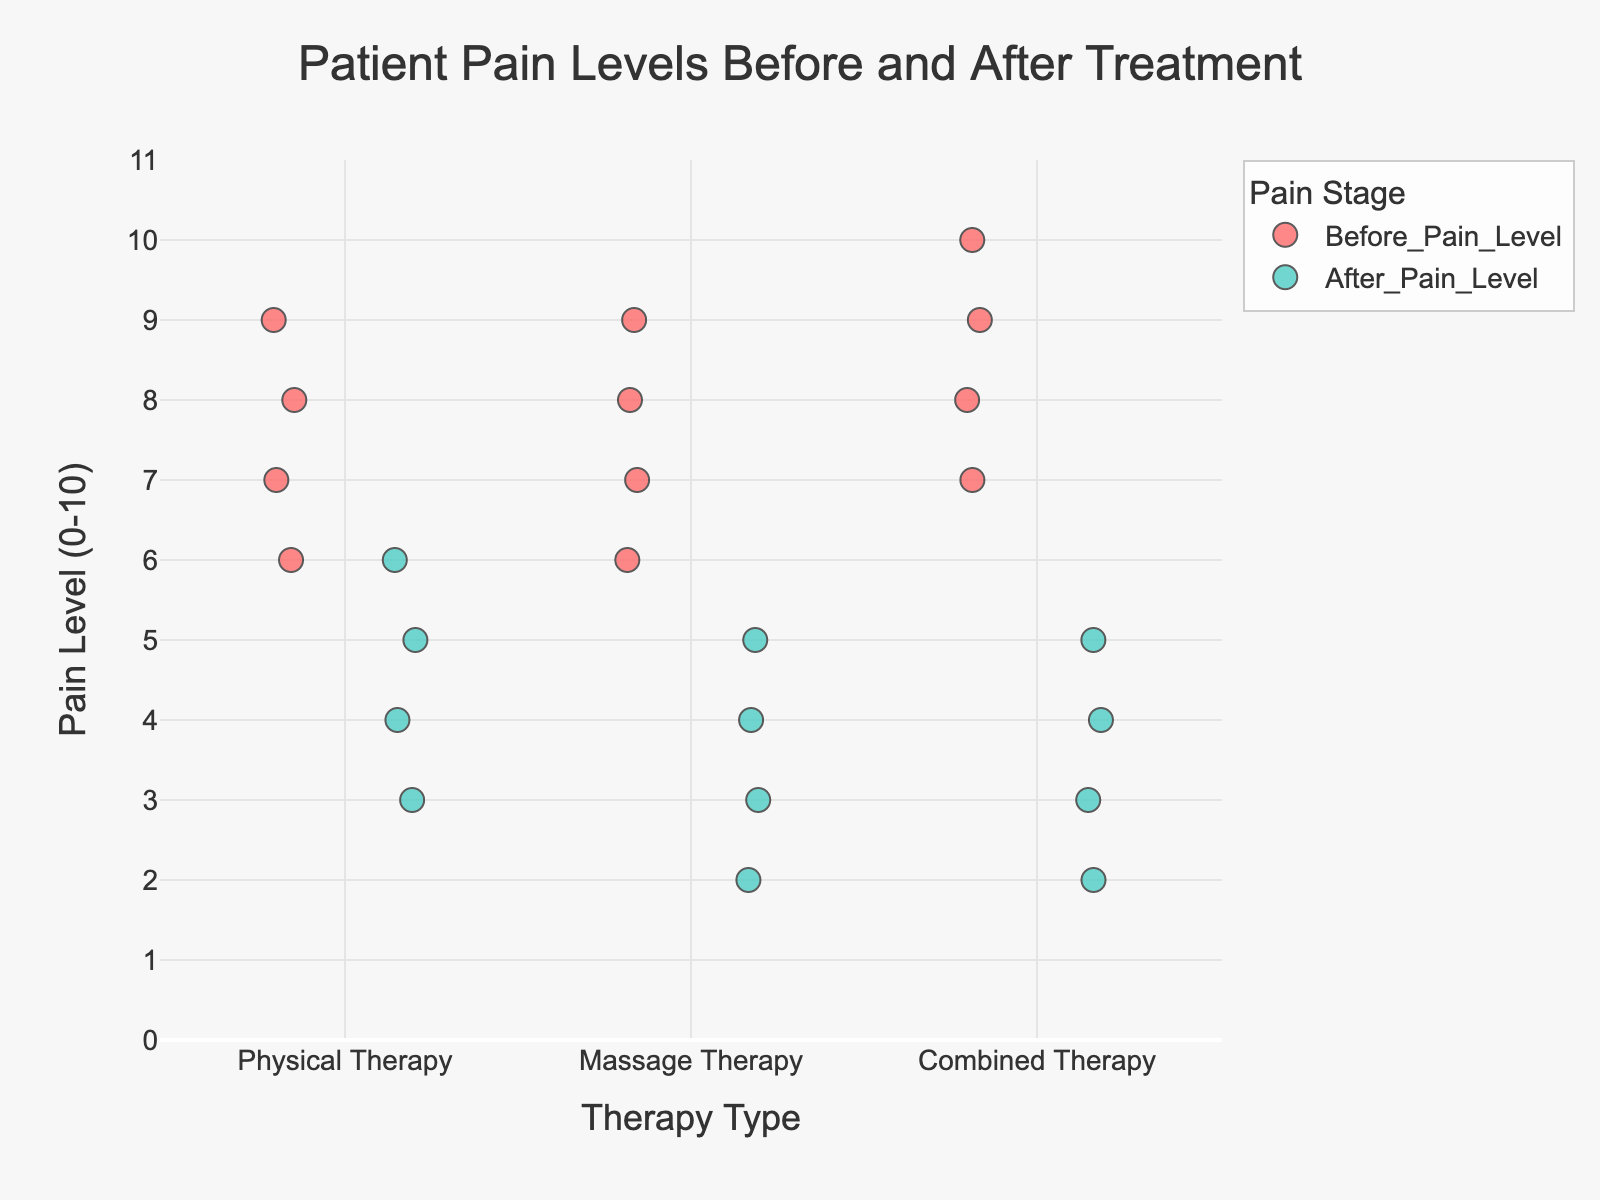How many therapy types are used in the figure? The figure shows three different therapy types along the x-axis: Physical Therapy, Massage Therapy, and Combined Therapy. Count these categories.
Answer: 3 What is the title of the figure? The title is located at the top of the figure and summarizes what the plot represents: "Patient Pain Levels Before and After Treatment".
Answer: Patient Pain Levels Before and After Treatment Which pain stage is colored green? By observing the legend on the figure, the green color corresponds to the 'After_Pain_Level' pain stage.
Answer: After_Pain_Level What is the maximum pain level recorded before treatment in any therapy type? The y-axis ranges from 0 to 10 representing pain levels. The highest point in the 'Before_Pain_Level' category, colored red, appears to be at 10 in Combined Therapy for Olivia White.
Answer: 10 How many patients reported a pain level of 9 before treatment? Locate the red points (Before_Pain_Level) at the pain level 9 on the y-axis. There are three points: Michael Brown (Physical Therapy), Christopher Anderson (Combined Therapy), and Olivia White (Combined Therapy).
Answer: 3 Which therapy type shows the greatest reduction in pain levels on average? Calculate the average reduction for each therapy type by subtracting 'After_Pain_Level' from 'Before_Pain_Level' for each patient. The average reductions are:
- Physical Therapy: (8-5 + 7-4 + 9-6 + 6-3)/4 = 3.5
- Massage Therapy: (7-3 + 8-4 + 6-2 + 9-5)/4 = 3.5
- Combined Therapy: (9-4 + 8-3 + 7-2 + 10-5)/4 = 4
Combined Therapy has the greatest average reduction.
Answer: Combined Therapy Which patient in Massage Therapy had the least pain reduction? For Massage Therapy, compare the difference between 'Before_Pain_Level' and 'After_Pain_Level' for each patient. David Wilson: 7-3=4, Jessica Lee: 8-4=4, Robert Taylor: 6-2=4, Amanda Martinez: 9-5=4. Since all have the same reduction, any of these patients had the least reduction.
Answer: Robert Taylor (or any of the other names) What is the average pain level after treatment for patients in Physical Therapy? Calculate the average 'After_Pain_Level' for Physical Therapy: (5+4+6+3)/4 = 4.5.
Answer: 4.5 How does the pain reduction in one therapy type compare to another? To compare reductions, calculate the difference of 'Before_Pain_Level' and 'After_Pain_Level' for each patient and then average these differences within each therapy type. Repeating earlier calculations:
- Physical Therapy: 3.5
- Massage Therapy: 3.5
- Combined Therapy: 4
Compare each pair of these values. Combined Therapy has a higher average reduction than both Physical Therapy and Massage Therapy, while Physical Therapy and Massage Therapy have equal average reductions.
Answer: Combined Therapy > Physical Therapy = Massage Therapy 